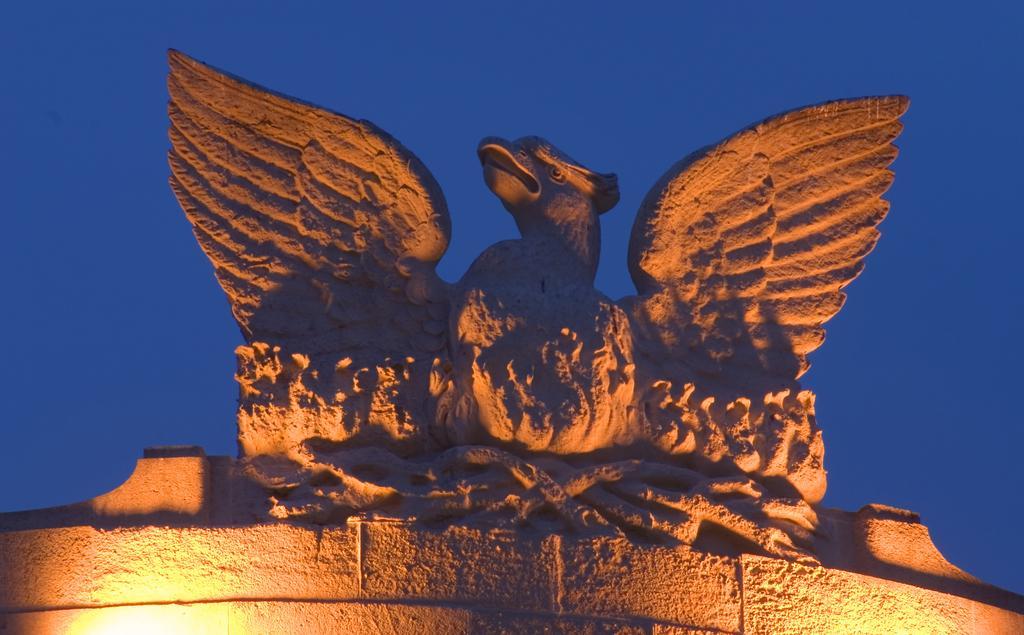Describe this image in one or two sentences. At the bottom of the image there is a wall with lights. On the top of the wall there is a statue of a bird. Behind the statue there is sky. 